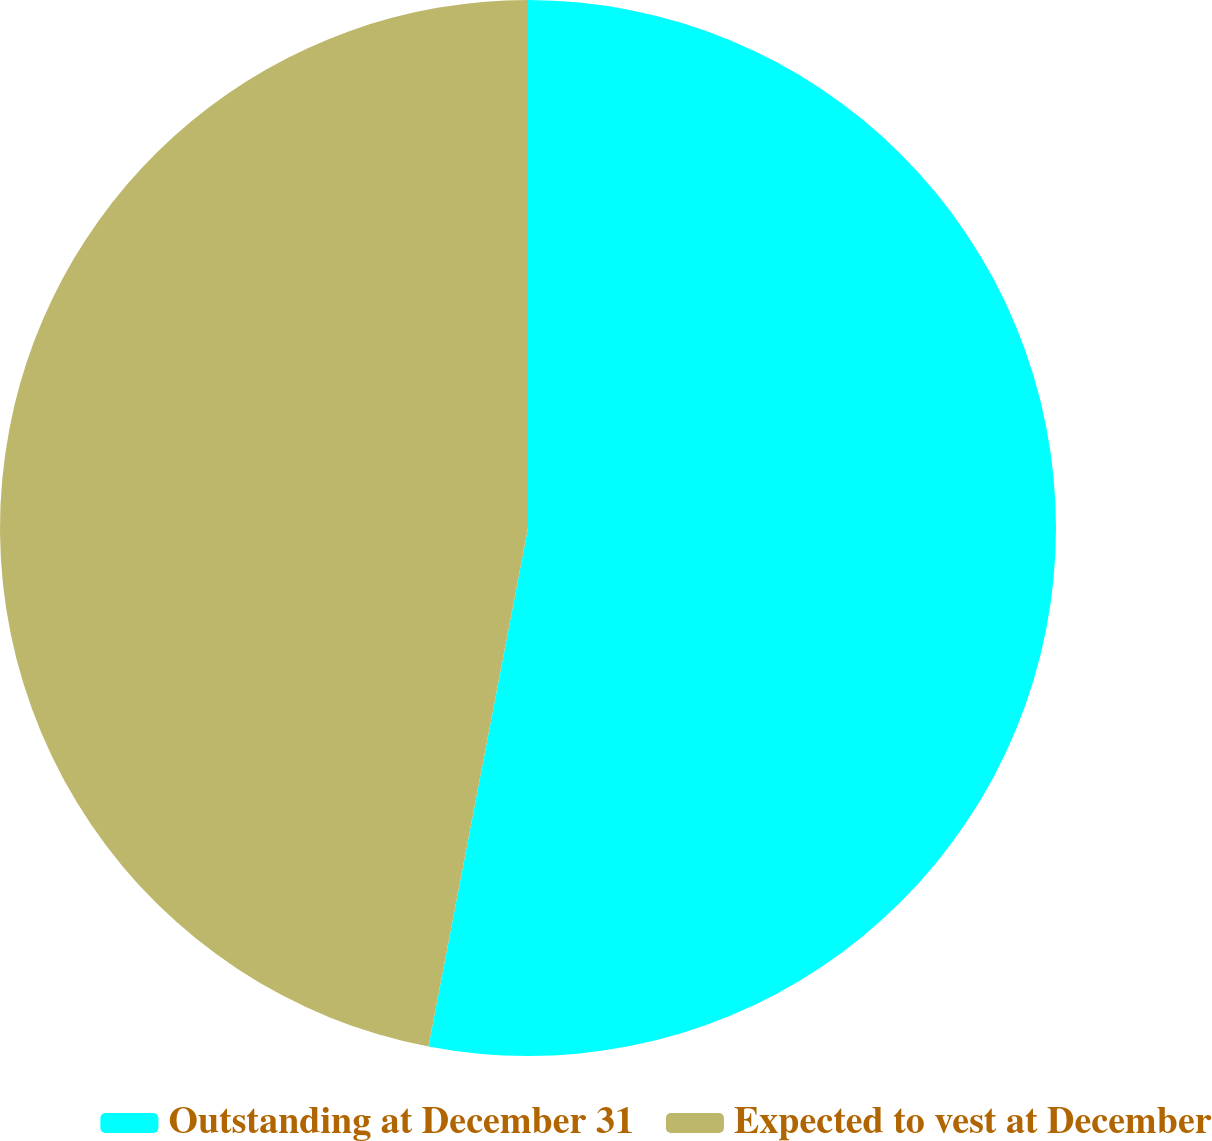Convert chart. <chart><loc_0><loc_0><loc_500><loc_500><pie_chart><fcel>Outstanding at December 31<fcel>Expected to vest at December<nl><fcel>53.02%<fcel>46.98%<nl></chart> 